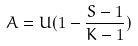<formula> <loc_0><loc_0><loc_500><loc_500>A = U ( 1 - \frac { S - 1 } { K - 1 } )</formula> 